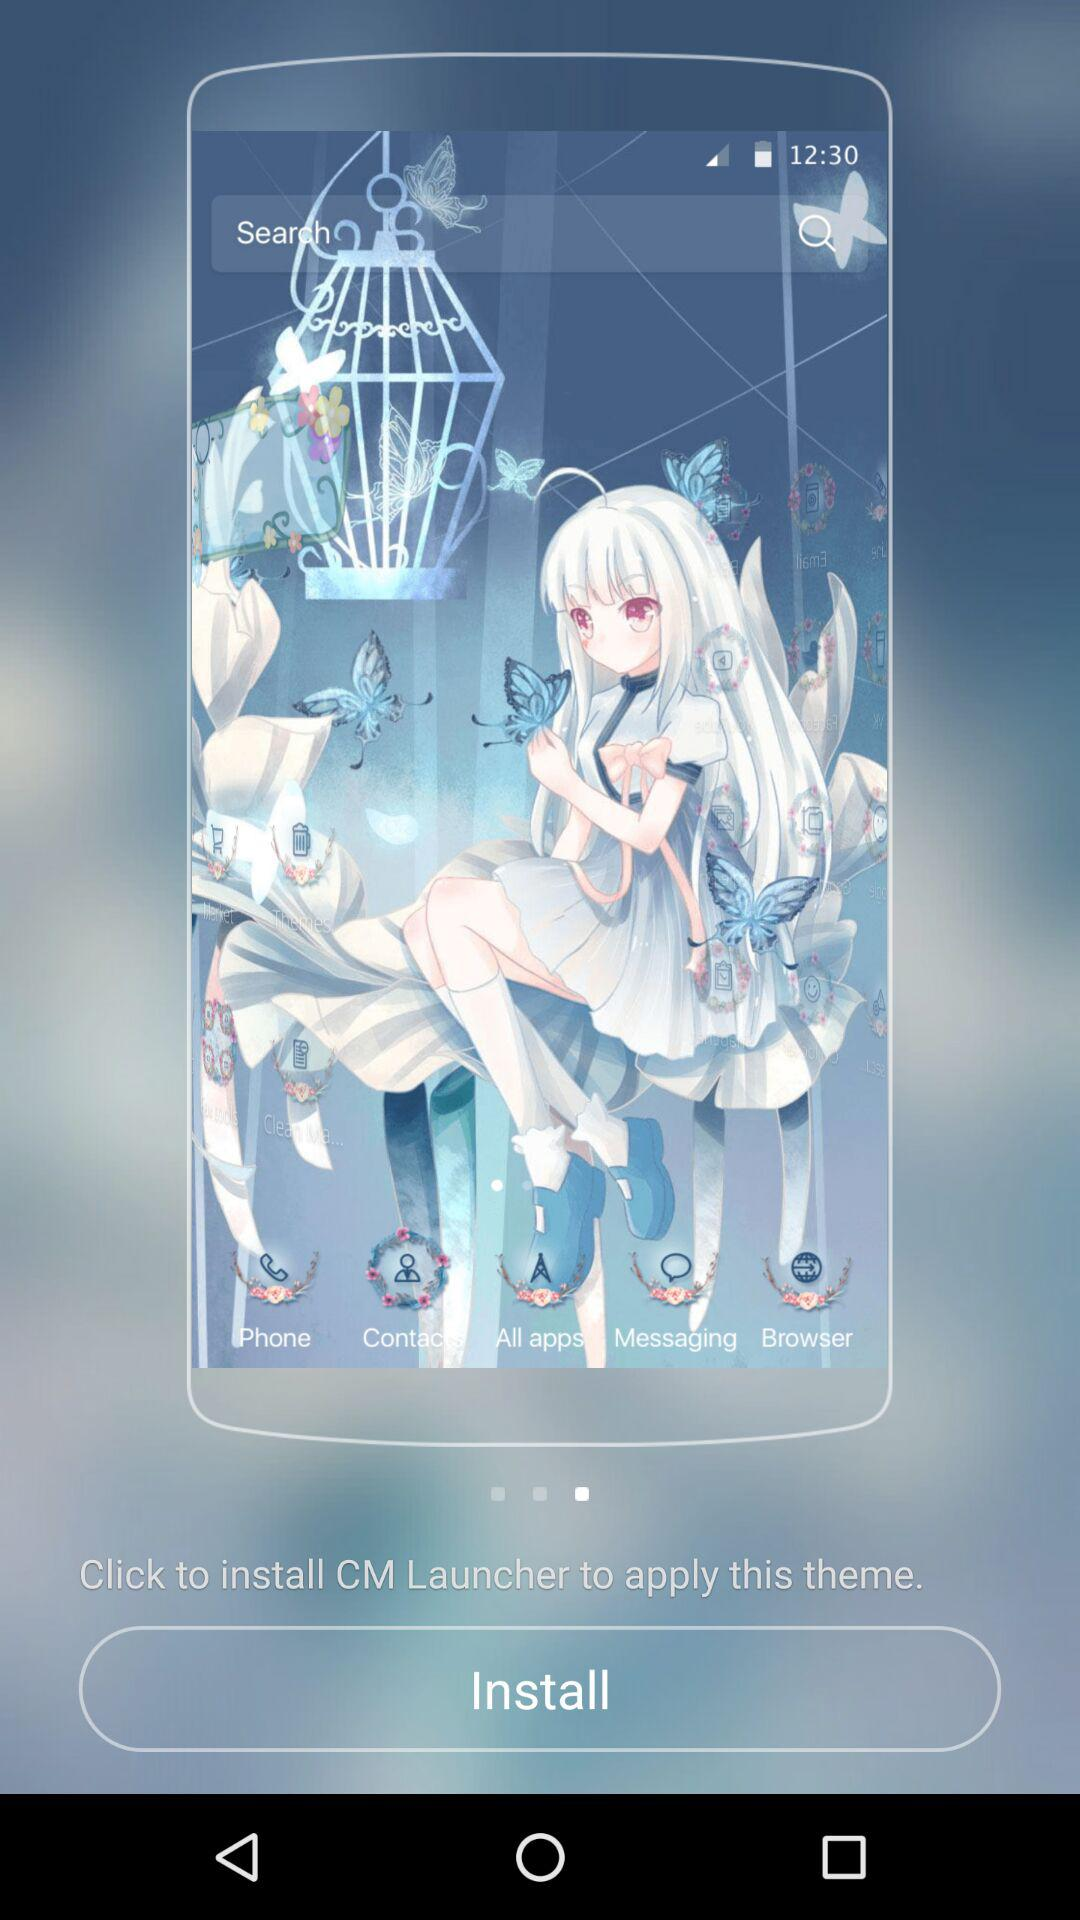What should be clicked to apply this theme? To apply this theme, click to install CM Launcher. 